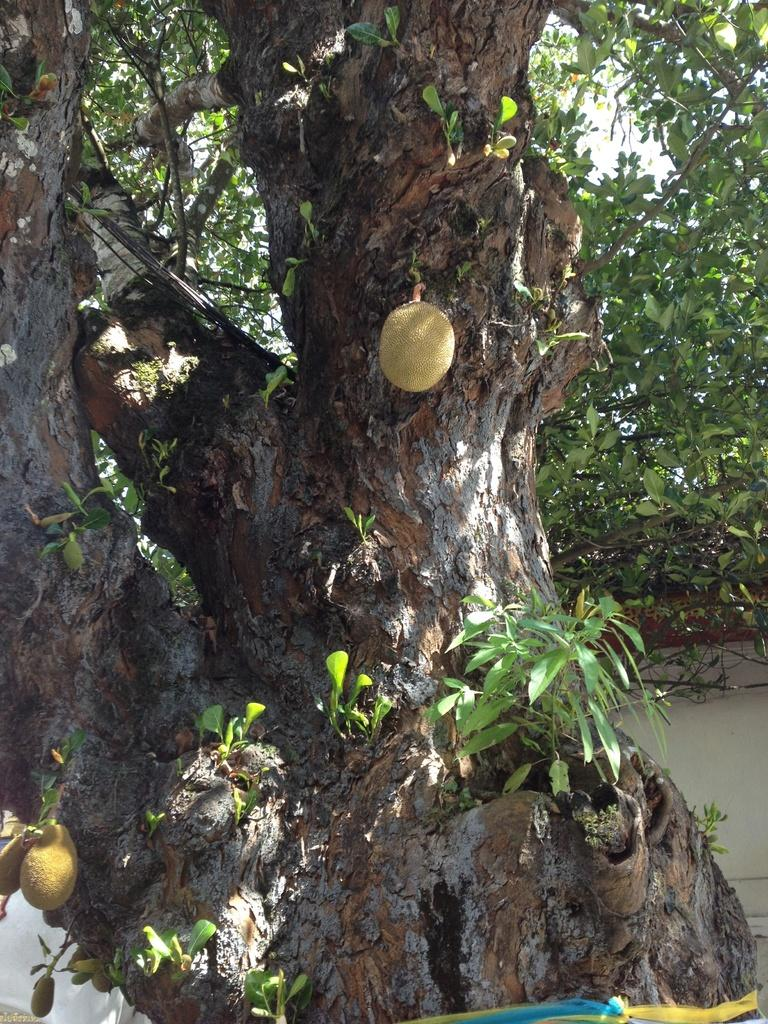What is the main subject of the picture? The main subject of the picture is a huge tree. Are there any fruits visible on the tree? Yes, there are fruits on the tree trunk. What type of dress is hanging on the rail near the tree? There is no dress or rail present in the image; it only features a huge tree with fruits on the trunk. How many frogs can be seen sitting on the tree branches? There are no frogs visible in the image; it only features a huge tree with fruits on the trunk. 